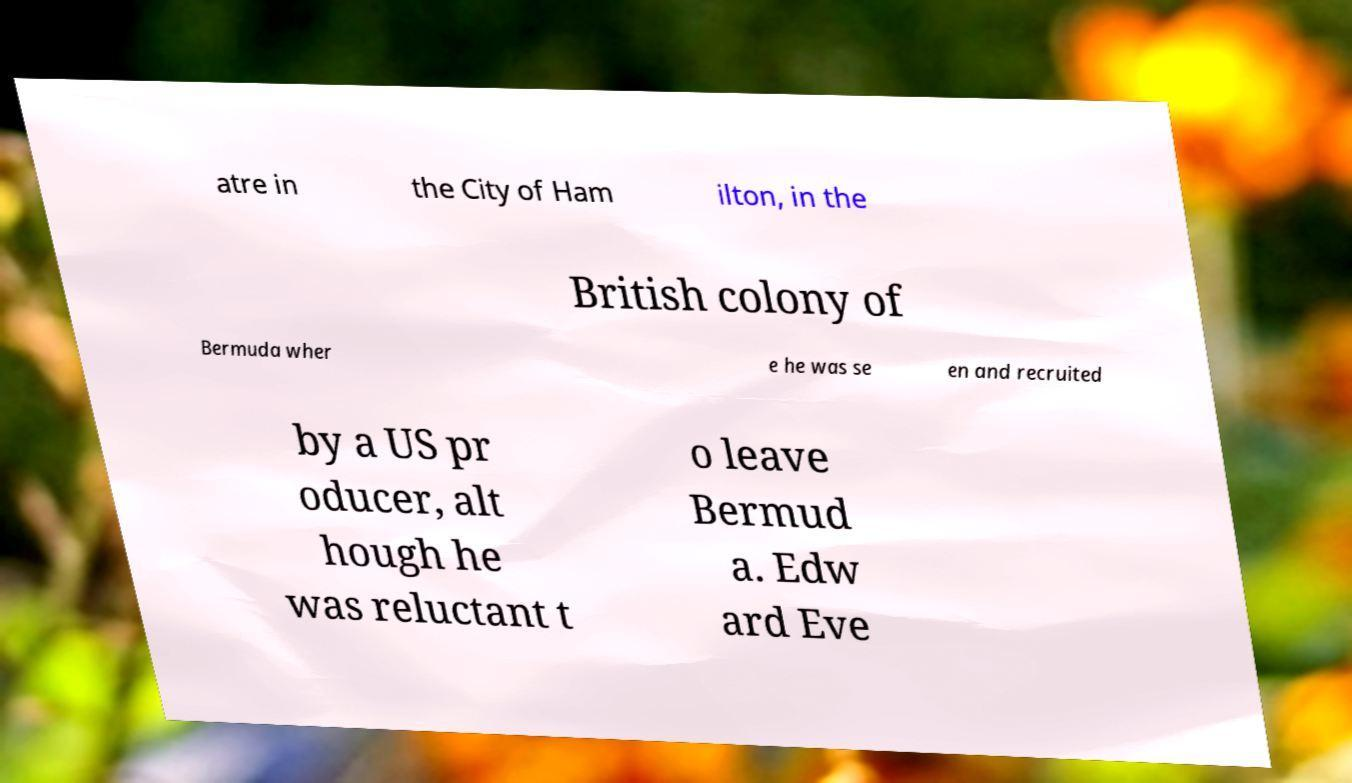Can you accurately transcribe the text from the provided image for me? atre in the City of Ham ilton, in the British colony of Bermuda wher e he was se en and recruited by a US pr oducer, alt hough he was reluctant t o leave Bermud a. Edw ard Eve 